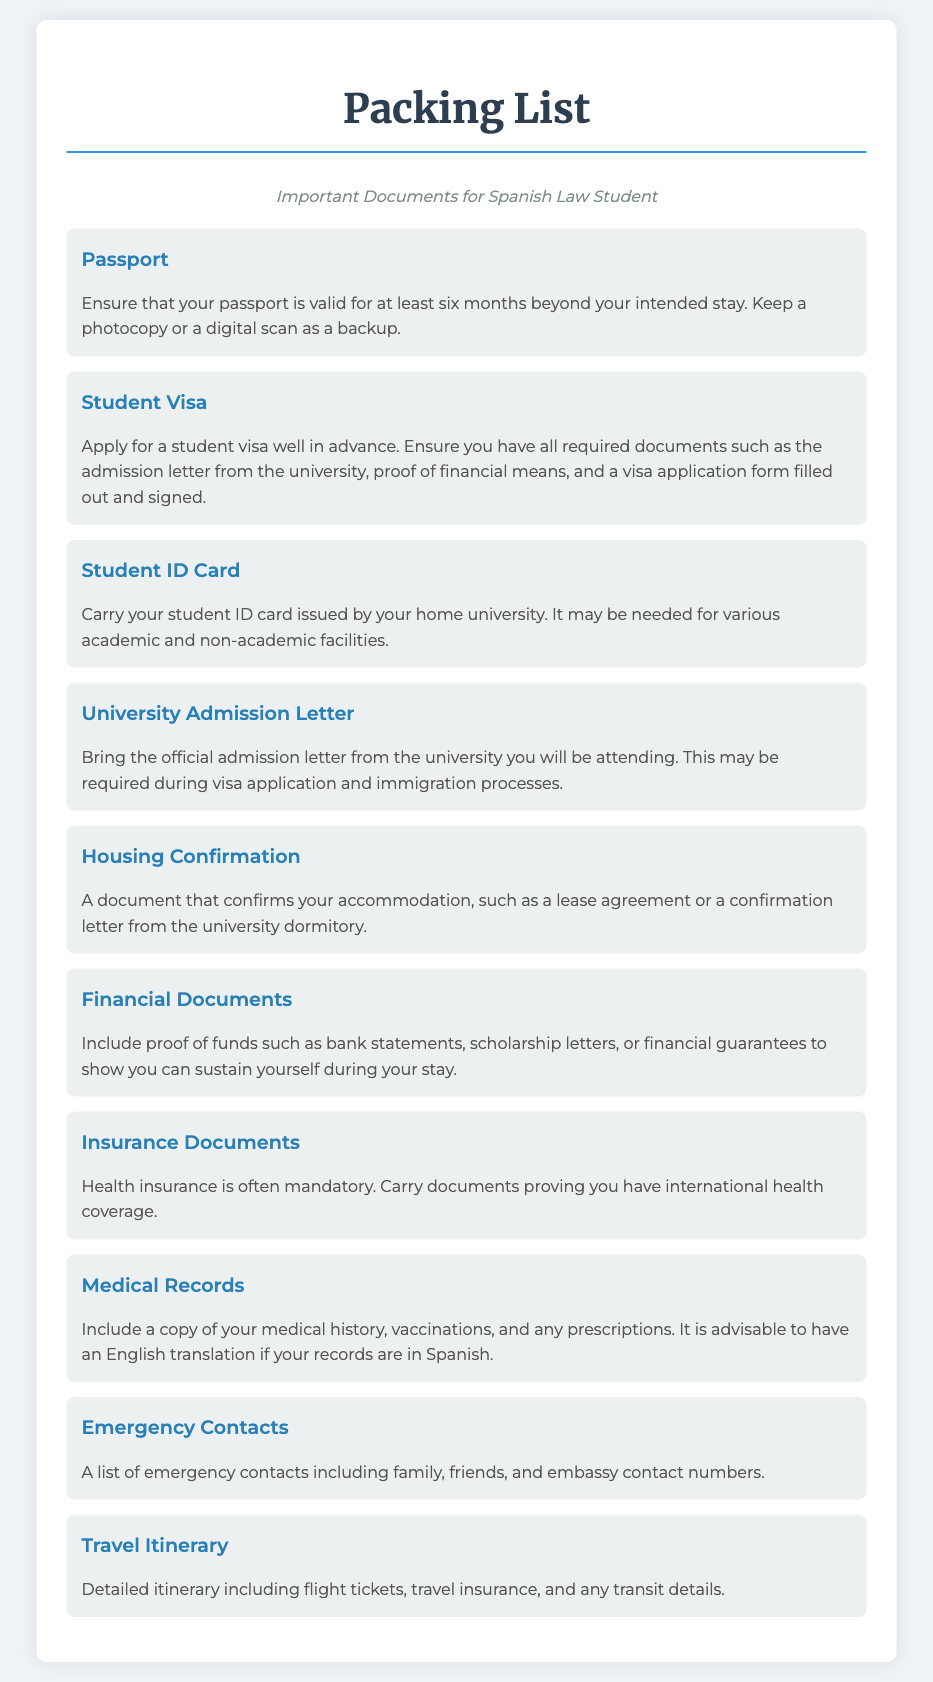what documents are essential for a Spanish law student? The essential documents listed are Passport, Student Visa, and Student ID Card.
Answer: Passport, Visa, Student ID how long must your passport be valid? The document states the passport must be valid for at least six months beyond your intended stay.
Answer: six months what document is required for visa application? The document mentions you need the official admission letter from the university for the visa application.
Answer: admission letter why should you carry a student ID card? The document specifies that a student ID card is needed for various academic and non-academic facilities.
Answer: for various academic and non-academic facilities what is necessary to prove financial means? The document states that you need to include proof of funds such as bank statements or financial guarantees.
Answer: proof of funds how should medical records be presented? The document advises having an English translation if your records are in Spanish.
Answer: English translation what should be included in the travel itinerary? According to the document, the travel itinerary should include flight tickets and travel insurance.
Answer: flight tickets, travel insurance what is often mandatory to carry for health coverage? The document indicates that health insurance is often mandatory.
Answer: Health insurance what type of confirmation is needed for housing? The document states that you need a document confirming your accommodation, such as a lease agreement.
Answer: lease agreement 